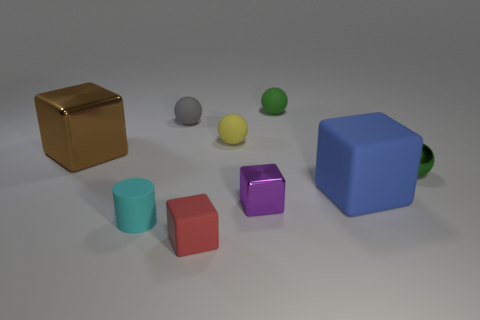Subtract all cyan spheres. Subtract all blue cubes. How many spheres are left? 4 Add 1 tiny yellow rubber cubes. How many objects exist? 10 Subtract all blocks. How many objects are left? 5 Subtract 0 blue spheres. How many objects are left? 9 Subtract all brown shiny blocks. Subtract all tiny gray spheres. How many objects are left? 7 Add 6 small shiny spheres. How many small shiny spheres are left? 7 Add 7 small yellow spheres. How many small yellow spheres exist? 8 